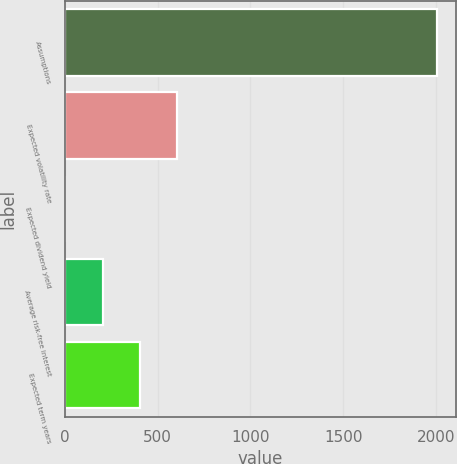<chart> <loc_0><loc_0><loc_500><loc_500><bar_chart><fcel>Assumptions<fcel>Expected volatility rate<fcel>Expected dividend yield<fcel>Average risk-free interest<fcel>Expected term years<nl><fcel>2007<fcel>604.15<fcel>2.92<fcel>203.33<fcel>403.74<nl></chart> 